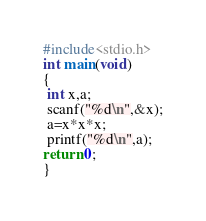<code> <loc_0><loc_0><loc_500><loc_500><_C_>#include<stdio.h>
int main(void)
{
 int x,a;
 scanf("%d\n",&x);
 a=x*x*x;
 printf("%d\n",a);
return 0;
}


</code> 